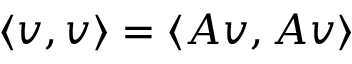<formula> <loc_0><loc_0><loc_500><loc_500>\langle v , v \rangle = \langle A v , A v \rangle</formula> 